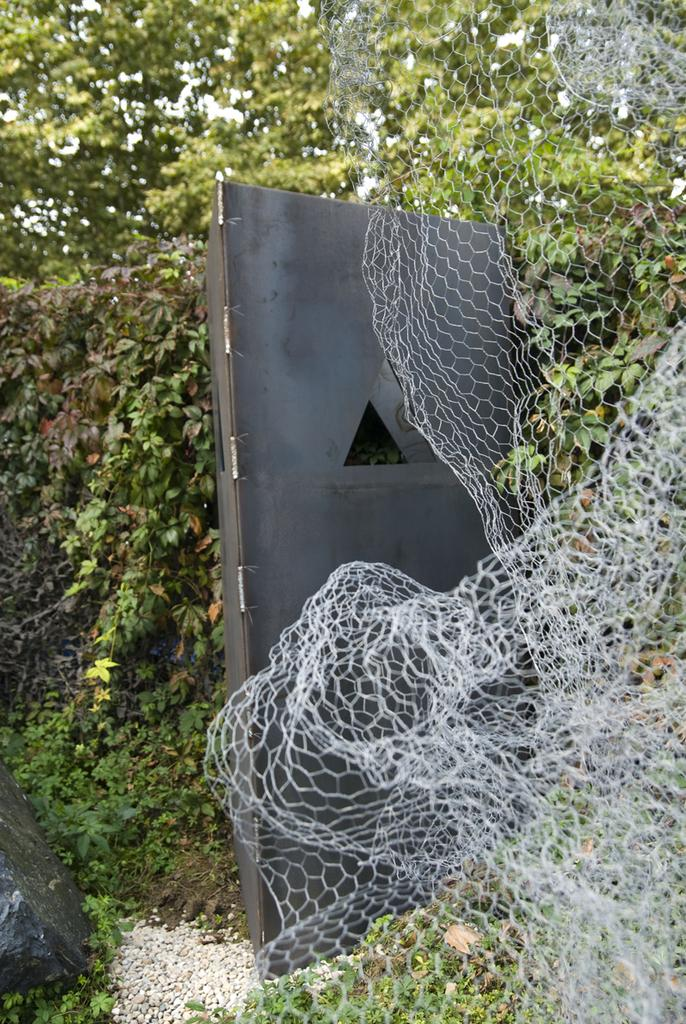What object is present in the image that is used for catching or holding things? There is a net in the image. What type of door can be seen in the image? There is a black color door in the image. What geological feature is present in the image? There is a rock in the image. What type of natural scenery is visible in the background of the image? There are trees in the background of the image. How does the hill in the image affect the desire of the person in the image? There is no hill or person present in the image, so this question cannot be answered. 